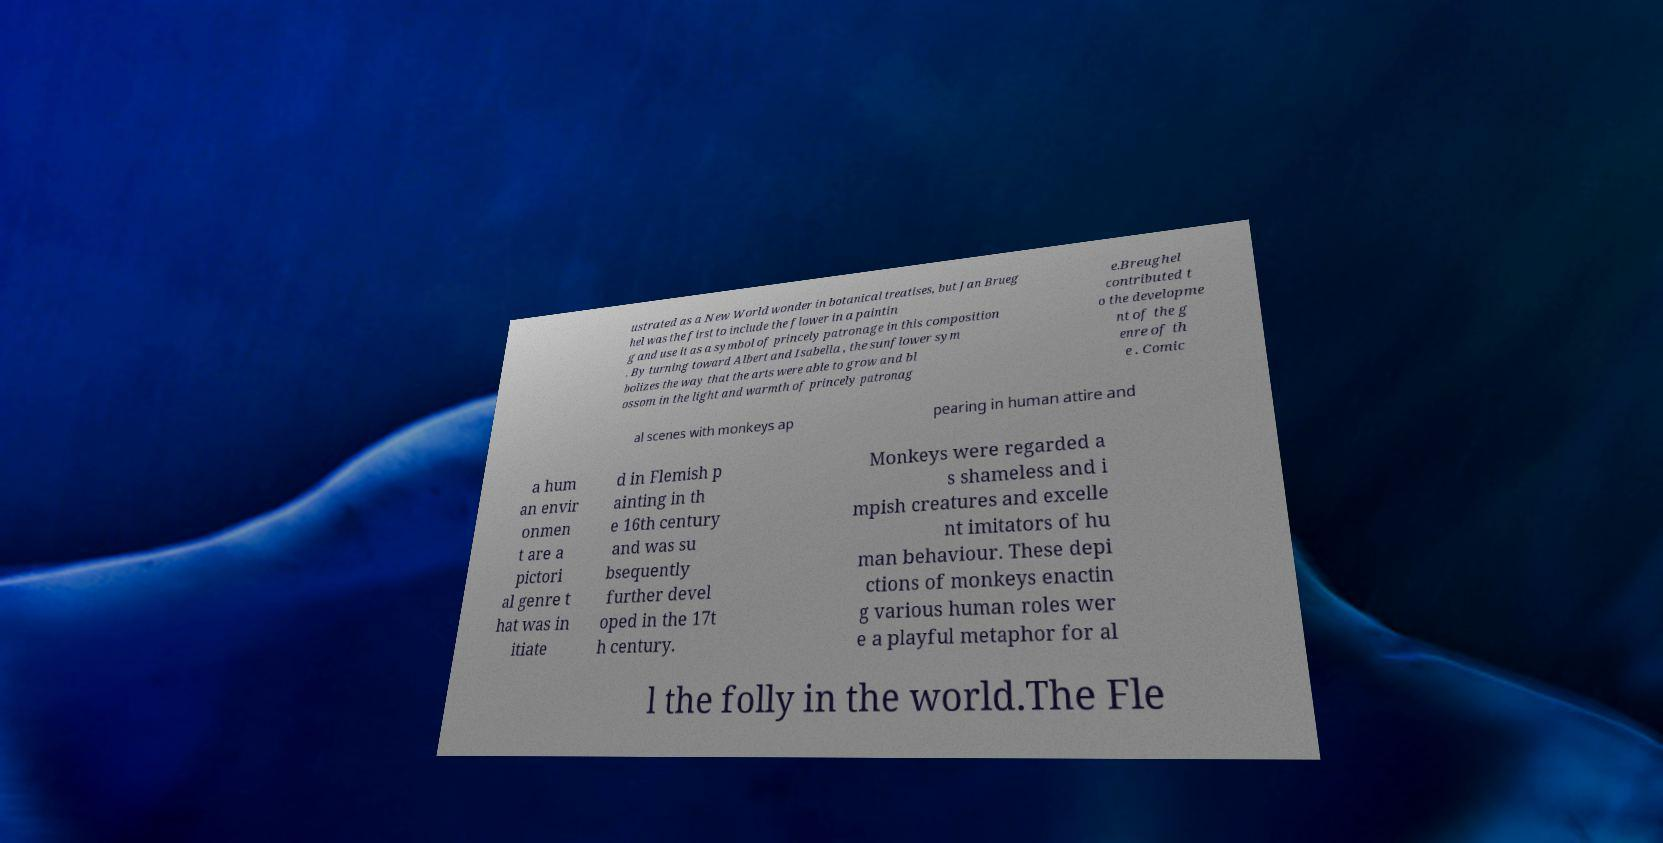Please read and relay the text visible in this image. What does it say? ustrated as a New World wonder in botanical treatises, but Jan Brueg hel was the first to include the flower in a paintin g and use it as a symbol of princely patronage in this composition . By turning toward Albert and Isabella , the sunflower sym bolizes the way that the arts were able to grow and bl ossom in the light and warmth of princely patronag e.Breughel contributed t o the developme nt of the g enre of th e . Comic al scenes with monkeys ap pearing in human attire and a hum an envir onmen t are a pictori al genre t hat was in itiate d in Flemish p ainting in th e 16th century and was su bsequently further devel oped in the 17t h century. Monkeys were regarded a s shameless and i mpish creatures and excelle nt imitators of hu man behaviour. These depi ctions of monkeys enactin g various human roles wer e a playful metaphor for al l the folly in the world.The Fle 